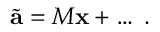Convert formula to latex. <formula><loc_0><loc_0><loc_500><loc_500>\tilde { a } = M { x } + \dots \, .</formula> 